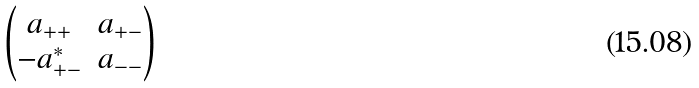Convert formula to latex. <formula><loc_0><loc_0><loc_500><loc_500>\begin{pmatrix} a _ { + + } & a _ { + - } \\ - a _ { + - } ^ { * } & a _ { - - } \end{pmatrix}</formula> 